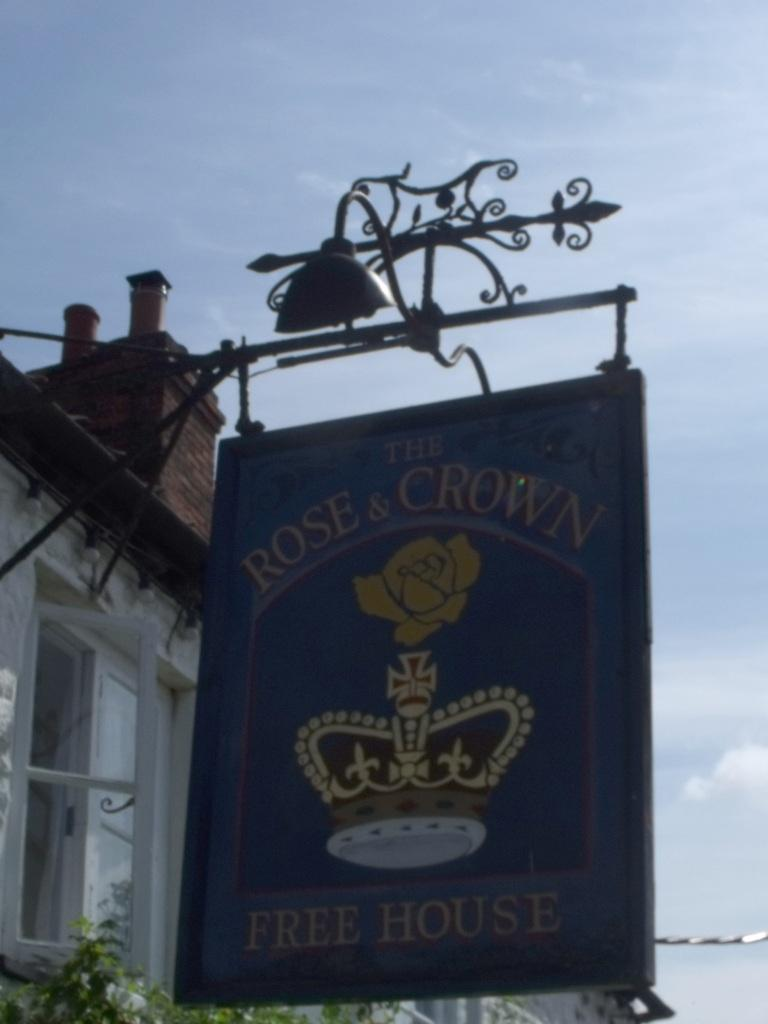What is the main object in the image? There is a pole in the image. What is attached to the pole? There is a board on the pole. What can be seen on the board? Something is written on the board. What can be seen in the background of the image? There is a building and green leaves visible in the background. What else is visible in the background of the image? The sky is visible in the background of the image. Where is the playground located in the image? There is no playground present in the image. How many chairs can be seen in the image? There are no chairs visible in the image. 